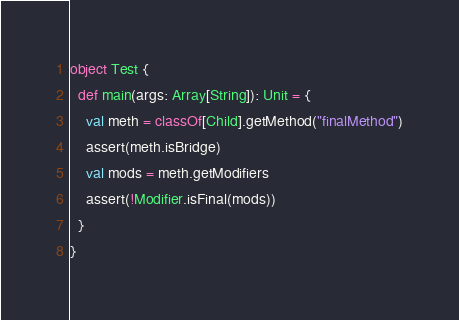<code> <loc_0><loc_0><loc_500><loc_500><_Scala_>
object Test {
  def main(args: Array[String]): Unit = {
    val meth = classOf[Child].getMethod("finalMethod")
    assert(meth.isBridge)
    val mods = meth.getModifiers
    assert(!Modifier.isFinal(mods))
  }
}
</code> 